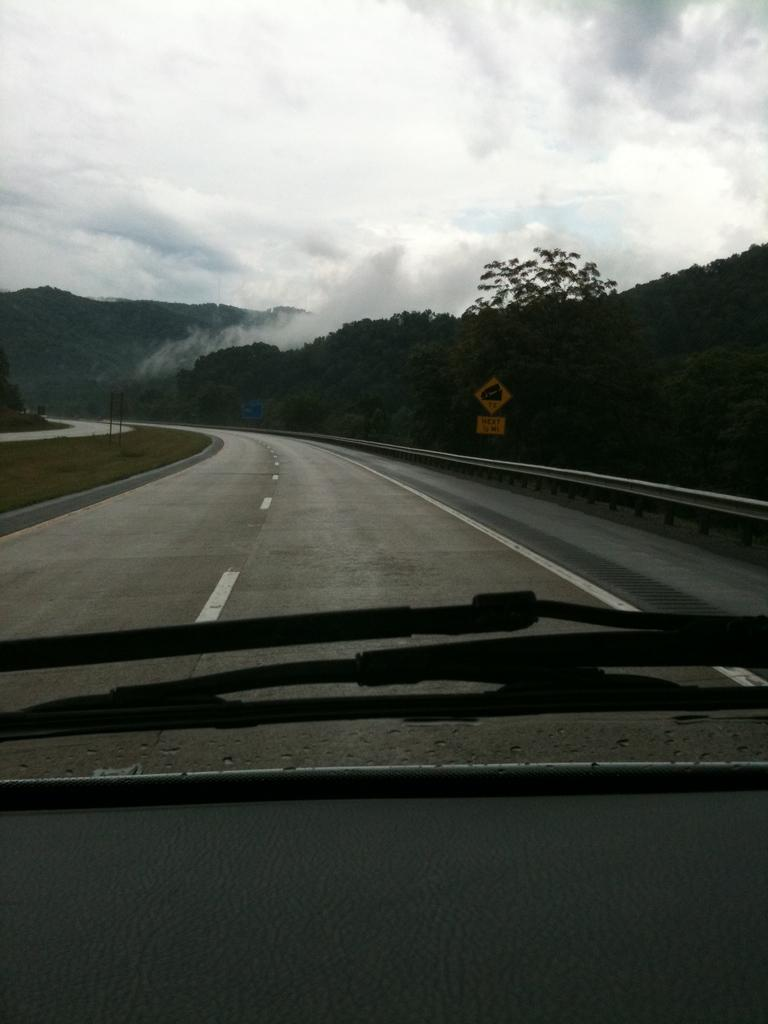What can be seen in the sky in the image? The sky with clouds is visible in the image. What type of natural feature is present in the image? There are hills in the image. What man-made object is present in the image? There is a sign board in the image. What might be used to control traffic or pedestrians in the image? Barriers are present in the image. What might be used to clean or clear a surface in the image? Wipers are visible in the image. What type of surface is present in the image? There is a road with a margin in the image. Where can you buy a ticket for the park in the image? There is no park or ticket booth present in the image. What type of buildings can be seen in the downtown area of the image? There is no downtown area present in the image. 